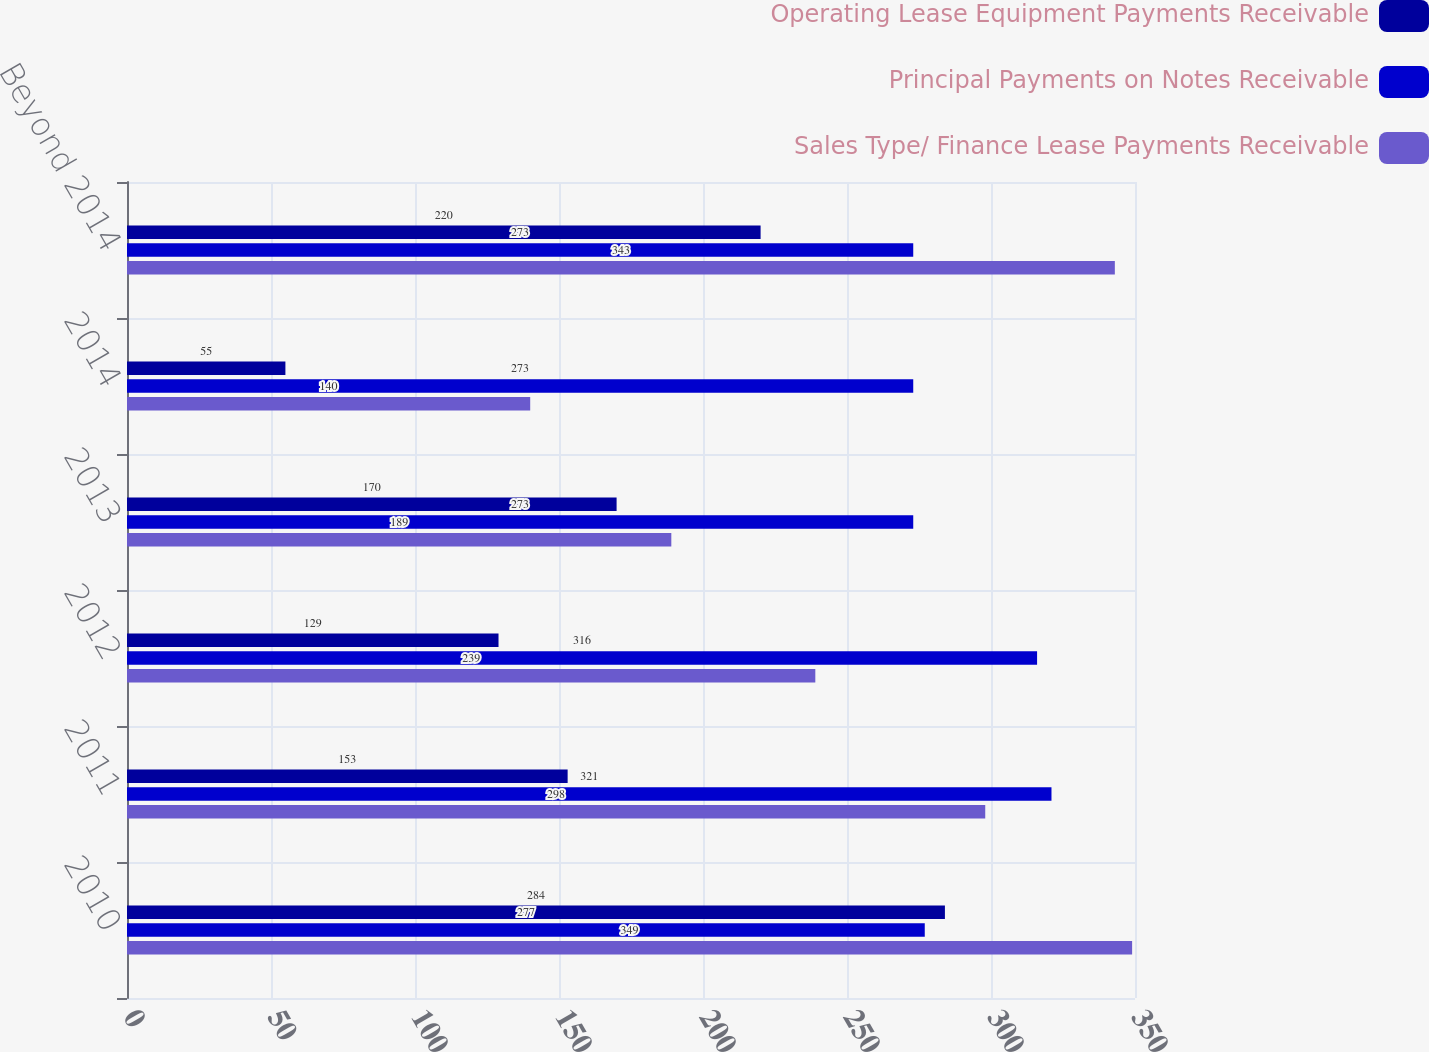<chart> <loc_0><loc_0><loc_500><loc_500><stacked_bar_chart><ecel><fcel>2010<fcel>2011<fcel>2012<fcel>2013<fcel>2014<fcel>Beyond 2014<nl><fcel>Operating Lease Equipment Payments Receivable<fcel>284<fcel>153<fcel>129<fcel>170<fcel>55<fcel>220<nl><fcel>Principal Payments on Notes Receivable<fcel>277<fcel>321<fcel>316<fcel>273<fcel>273<fcel>273<nl><fcel>Sales Type/ Finance Lease Payments Receivable<fcel>349<fcel>298<fcel>239<fcel>189<fcel>140<fcel>343<nl></chart> 